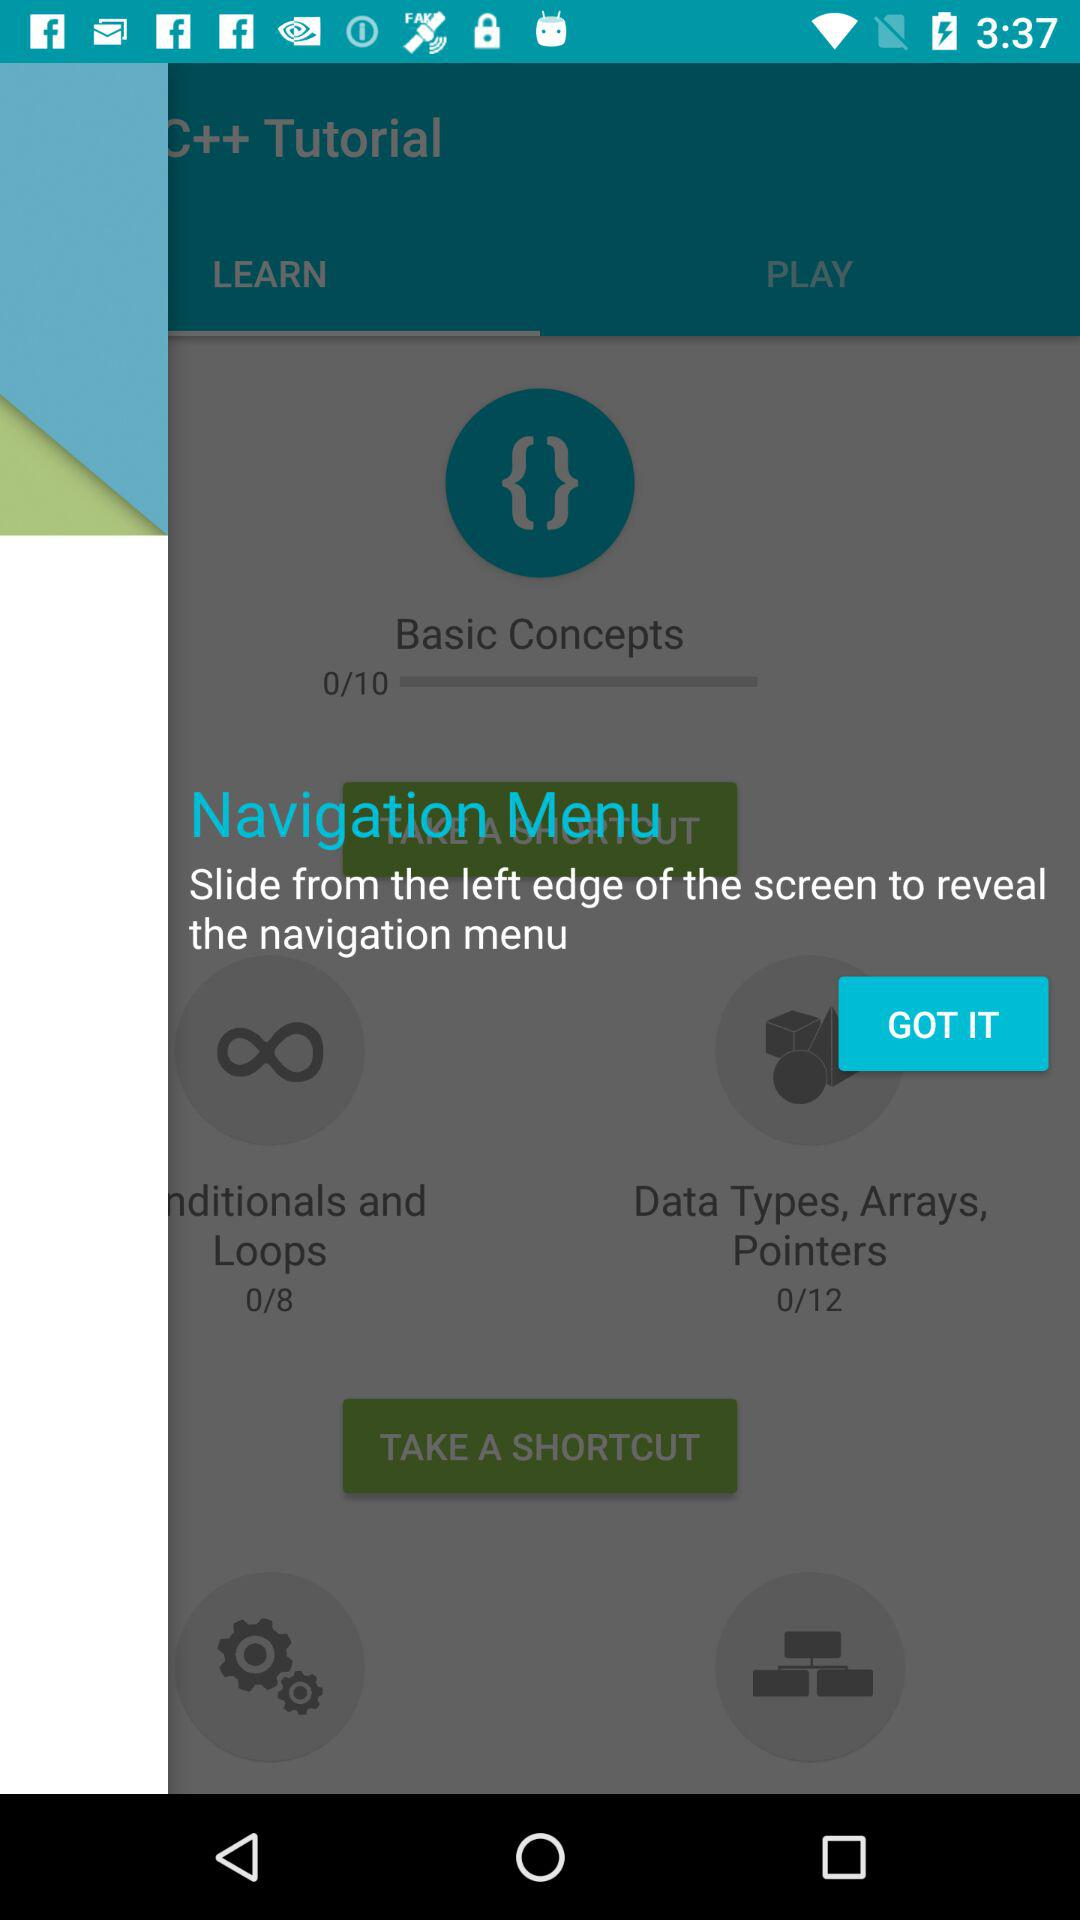How many more lessons are there for Data Types, Arrays, Pointers than for Basic Concepts?
Answer the question using a single word or phrase. 2 